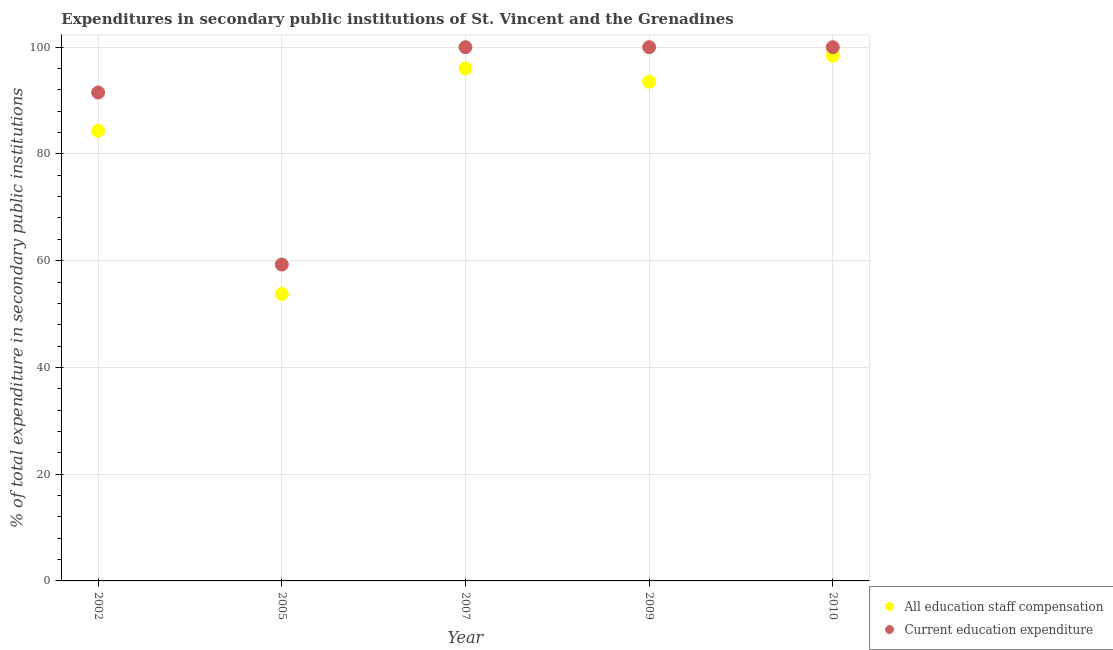What is the expenditure in education in 2002?
Make the answer very short. 91.52. Across all years, what is the maximum expenditure in education?
Your response must be concise. 100. Across all years, what is the minimum expenditure in staff compensation?
Offer a very short reply. 53.76. In which year was the expenditure in staff compensation maximum?
Make the answer very short. 2010. What is the total expenditure in education in the graph?
Provide a succinct answer. 450.79. What is the difference between the expenditure in staff compensation in 2005 and that in 2007?
Ensure brevity in your answer.  -42.26. What is the difference between the expenditure in education in 2007 and the expenditure in staff compensation in 2009?
Keep it short and to the point. 6.45. What is the average expenditure in education per year?
Keep it short and to the point. 90.16. In the year 2010, what is the difference between the expenditure in education and expenditure in staff compensation?
Make the answer very short. 1.6. What is the ratio of the expenditure in education in 2002 to that in 2005?
Offer a very short reply. 1.54. Is the expenditure in education in 2007 less than that in 2009?
Offer a very short reply. No. What is the difference between the highest and the second highest expenditure in staff compensation?
Give a very brief answer. 2.37. What is the difference between the highest and the lowest expenditure in staff compensation?
Provide a succinct answer. 44.63. What is the difference between two consecutive major ticks on the Y-axis?
Provide a short and direct response. 20. Does the graph contain any zero values?
Give a very brief answer. No. Where does the legend appear in the graph?
Offer a terse response. Bottom right. How many legend labels are there?
Keep it short and to the point. 2. What is the title of the graph?
Make the answer very short. Expenditures in secondary public institutions of St. Vincent and the Grenadines. What is the label or title of the X-axis?
Ensure brevity in your answer.  Year. What is the label or title of the Y-axis?
Keep it short and to the point. % of total expenditure in secondary public institutions. What is the % of total expenditure in secondary public institutions of All education staff compensation in 2002?
Keep it short and to the point. 84.33. What is the % of total expenditure in secondary public institutions in Current education expenditure in 2002?
Your response must be concise. 91.52. What is the % of total expenditure in secondary public institutions in All education staff compensation in 2005?
Make the answer very short. 53.76. What is the % of total expenditure in secondary public institutions in Current education expenditure in 2005?
Provide a short and direct response. 59.28. What is the % of total expenditure in secondary public institutions in All education staff compensation in 2007?
Offer a very short reply. 96.03. What is the % of total expenditure in secondary public institutions of All education staff compensation in 2009?
Make the answer very short. 93.55. What is the % of total expenditure in secondary public institutions of Current education expenditure in 2009?
Ensure brevity in your answer.  100. What is the % of total expenditure in secondary public institutions of All education staff compensation in 2010?
Offer a very short reply. 98.4. What is the % of total expenditure in secondary public institutions in Current education expenditure in 2010?
Ensure brevity in your answer.  100. Across all years, what is the maximum % of total expenditure in secondary public institutions in All education staff compensation?
Keep it short and to the point. 98.4. Across all years, what is the minimum % of total expenditure in secondary public institutions in All education staff compensation?
Ensure brevity in your answer.  53.76. Across all years, what is the minimum % of total expenditure in secondary public institutions of Current education expenditure?
Give a very brief answer. 59.28. What is the total % of total expenditure in secondary public institutions in All education staff compensation in the graph?
Ensure brevity in your answer.  426.07. What is the total % of total expenditure in secondary public institutions in Current education expenditure in the graph?
Provide a succinct answer. 450.79. What is the difference between the % of total expenditure in secondary public institutions in All education staff compensation in 2002 and that in 2005?
Give a very brief answer. 30.57. What is the difference between the % of total expenditure in secondary public institutions of Current education expenditure in 2002 and that in 2005?
Give a very brief answer. 32.24. What is the difference between the % of total expenditure in secondary public institutions of All education staff compensation in 2002 and that in 2007?
Keep it short and to the point. -11.7. What is the difference between the % of total expenditure in secondary public institutions in Current education expenditure in 2002 and that in 2007?
Your answer should be very brief. -8.48. What is the difference between the % of total expenditure in secondary public institutions in All education staff compensation in 2002 and that in 2009?
Ensure brevity in your answer.  -9.22. What is the difference between the % of total expenditure in secondary public institutions in Current education expenditure in 2002 and that in 2009?
Give a very brief answer. -8.48. What is the difference between the % of total expenditure in secondary public institutions in All education staff compensation in 2002 and that in 2010?
Keep it short and to the point. -14.07. What is the difference between the % of total expenditure in secondary public institutions of Current education expenditure in 2002 and that in 2010?
Give a very brief answer. -8.48. What is the difference between the % of total expenditure in secondary public institutions in All education staff compensation in 2005 and that in 2007?
Keep it short and to the point. -42.26. What is the difference between the % of total expenditure in secondary public institutions of Current education expenditure in 2005 and that in 2007?
Offer a terse response. -40.72. What is the difference between the % of total expenditure in secondary public institutions of All education staff compensation in 2005 and that in 2009?
Make the answer very short. -39.78. What is the difference between the % of total expenditure in secondary public institutions of Current education expenditure in 2005 and that in 2009?
Keep it short and to the point. -40.72. What is the difference between the % of total expenditure in secondary public institutions in All education staff compensation in 2005 and that in 2010?
Ensure brevity in your answer.  -44.63. What is the difference between the % of total expenditure in secondary public institutions of Current education expenditure in 2005 and that in 2010?
Your answer should be very brief. -40.72. What is the difference between the % of total expenditure in secondary public institutions in All education staff compensation in 2007 and that in 2009?
Your answer should be very brief. 2.48. What is the difference between the % of total expenditure in secondary public institutions of Current education expenditure in 2007 and that in 2009?
Provide a succinct answer. 0. What is the difference between the % of total expenditure in secondary public institutions in All education staff compensation in 2007 and that in 2010?
Your answer should be compact. -2.37. What is the difference between the % of total expenditure in secondary public institutions in All education staff compensation in 2009 and that in 2010?
Make the answer very short. -4.85. What is the difference between the % of total expenditure in secondary public institutions of Current education expenditure in 2009 and that in 2010?
Your answer should be very brief. 0. What is the difference between the % of total expenditure in secondary public institutions in All education staff compensation in 2002 and the % of total expenditure in secondary public institutions in Current education expenditure in 2005?
Your answer should be very brief. 25.05. What is the difference between the % of total expenditure in secondary public institutions of All education staff compensation in 2002 and the % of total expenditure in secondary public institutions of Current education expenditure in 2007?
Keep it short and to the point. -15.67. What is the difference between the % of total expenditure in secondary public institutions of All education staff compensation in 2002 and the % of total expenditure in secondary public institutions of Current education expenditure in 2009?
Ensure brevity in your answer.  -15.67. What is the difference between the % of total expenditure in secondary public institutions of All education staff compensation in 2002 and the % of total expenditure in secondary public institutions of Current education expenditure in 2010?
Offer a terse response. -15.67. What is the difference between the % of total expenditure in secondary public institutions in All education staff compensation in 2005 and the % of total expenditure in secondary public institutions in Current education expenditure in 2007?
Your response must be concise. -46.24. What is the difference between the % of total expenditure in secondary public institutions of All education staff compensation in 2005 and the % of total expenditure in secondary public institutions of Current education expenditure in 2009?
Keep it short and to the point. -46.24. What is the difference between the % of total expenditure in secondary public institutions in All education staff compensation in 2005 and the % of total expenditure in secondary public institutions in Current education expenditure in 2010?
Your answer should be very brief. -46.24. What is the difference between the % of total expenditure in secondary public institutions in All education staff compensation in 2007 and the % of total expenditure in secondary public institutions in Current education expenditure in 2009?
Make the answer very short. -3.97. What is the difference between the % of total expenditure in secondary public institutions in All education staff compensation in 2007 and the % of total expenditure in secondary public institutions in Current education expenditure in 2010?
Offer a terse response. -3.97. What is the difference between the % of total expenditure in secondary public institutions in All education staff compensation in 2009 and the % of total expenditure in secondary public institutions in Current education expenditure in 2010?
Provide a succinct answer. -6.45. What is the average % of total expenditure in secondary public institutions of All education staff compensation per year?
Your response must be concise. 85.21. What is the average % of total expenditure in secondary public institutions of Current education expenditure per year?
Ensure brevity in your answer.  90.16. In the year 2002, what is the difference between the % of total expenditure in secondary public institutions in All education staff compensation and % of total expenditure in secondary public institutions in Current education expenditure?
Give a very brief answer. -7.19. In the year 2005, what is the difference between the % of total expenditure in secondary public institutions of All education staff compensation and % of total expenditure in secondary public institutions of Current education expenditure?
Your answer should be compact. -5.51. In the year 2007, what is the difference between the % of total expenditure in secondary public institutions of All education staff compensation and % of total expenditure in secondary public institutions of Current education expenditure?
Offer a terse response. -3.97. In the year 2009, what is the difference between the % of total expenditure in secondary public institutions in All education staff compensation and % of total expenditure in secondary public institutions in Current education expenditure?
Give a very brief answer. -6.45. In the year 2010, what is the difference between the % of total expenditure in secondary public institutions in All education staff compensation and % of total expenditure in secondary public institutions in Current education expenditure?
Provide a short and direct response. -1.6. What is the ratio of the % of total expenditure in secondary public institutions of All education staff compensation in 2002 to that in 2005?
Give a very brief answer. 1.57. What is the ratio of the % of total expenditure in secondary public institutions of Current education expenditure in 2002 to that in 2005?
Make the answer very short. 1.54. What is the ratio of the % of total expenditure in secondary public institutions in All education staff compensation in 2002 to that in 2007?
Offer a very short reply. 0.88. What is the ratio of the % of total expenditure in secondary public institutions in Current education expenditure in 2002 to that in 2007?
Offer a very short reply. 0.92. What is the ratio of the % of total expenditure in secondary public institutions of All education staff compensation in 2002 to that in 2009?
Make the answer very short. 0.9. What is the ratio of the % of total expenditure in secondary public institutions in Current education expenditure in 2002 to that in 2009?
Offer a terse response. 0.92. What is the ratio of the % of total expenditure in secondary public institutions in All education staff compensation in 2002 to that in 2010?
Your answer should be very brief. 0.86. What is the ratio of the % of total expenditure in secondary public institutions of Current education expenditure in 2002 to that in 2010?
Provide a short and direct response. 0.92. What is the ratio of the % of total expenditure in secondary public institutions in All education staff compensation in 2005 to that in 2007?
Your answer should be compact. 0.56. What is the ratio of the % of total expenditure in secondary public institutions in Current education expenditure in 2005 to that in 2007?
Ensure brevity in your answer.  0.59. What is the ratio of the % of total expenditure in secondary public institutions of All education staff compensation in 2005 to that in 2009?
Your answer should be compact. 0.57. What is the ratio of the % of total expenditure in secondary public institutions in Current education expenditure in 2005 to that in 2009?
Provide a short and direct response. 0.59. What is the ratio of the % of total expenditure in secondary public institutions of All education staff compensation in 2005 to that in 2010?
Offer a very short reply. 0.55. What is the ratio of the % of total expenditure in secondary public institutions of Current education expenditure in 2005 to that in 2010?
Provide a short and direct response. 0.59. What is the ratio of the % of total expenditure in secondary public institutions of All education staff compensation in 2007 to that in 2009?
Provide a short and direct response. 1.03. What is the ratio of the % of total expenditure in secondary public institutions of All education staff compensation in 2007 to that in 2010?
Your answer should be compact. 0.98. What is the ratio of the % of total expenditure in secondary public institutions in All education staff compensation in 2009 to that in 2010?
Your answer should be very brief. 0.95. What is the difference between the highest and the second highest % of total expenditure in secondary public institutions of All education staff compensation?
Your answer should be compact. 2.37. What is the difference between the highest and the lowest % of total expenditure in secondary public institutions of All education staff compensation?
Keep it short and to the point. 44.63. What is the difference between the highest and the lowest % of total expenditure in secondary public institutions of Current education expenditure?
Give a very brief answer. 40.72. 